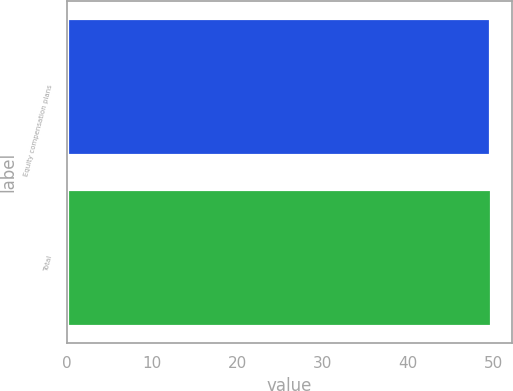Convert chart to OTSL. <chart><loc_0><loc_0><loc_500><loc_500><bar_chart><fcel>Equity compensation plans<fcel>Total<nl><fcel>49.61<fcel>49.71<nl></chart> 